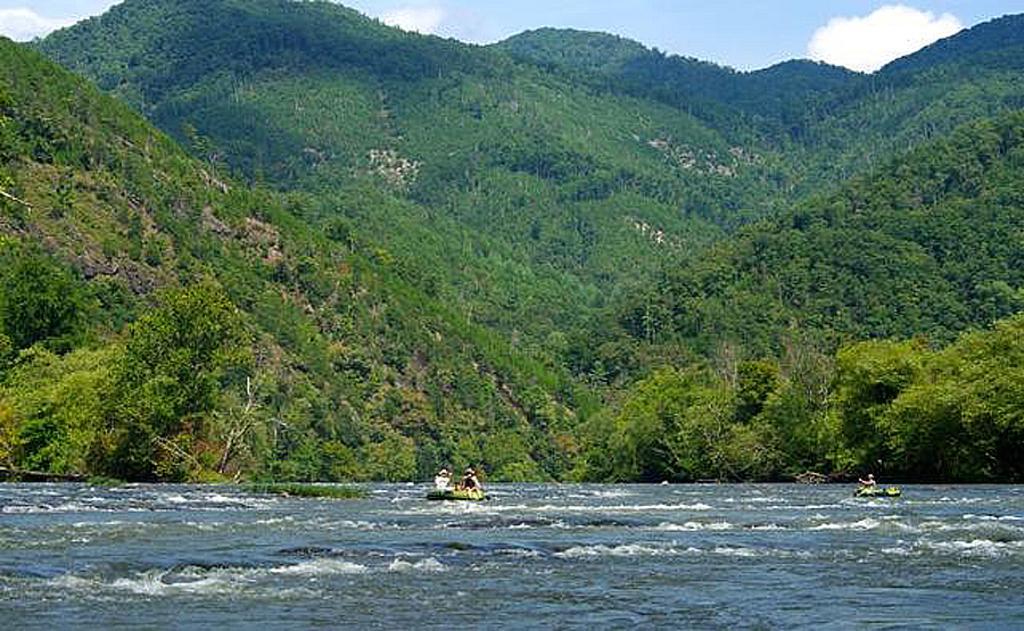In one or two sentences, can you explain what this image depicts? In this image we can see two boats on the water, there are some persons and trees, also we can see the sky with clouds. 